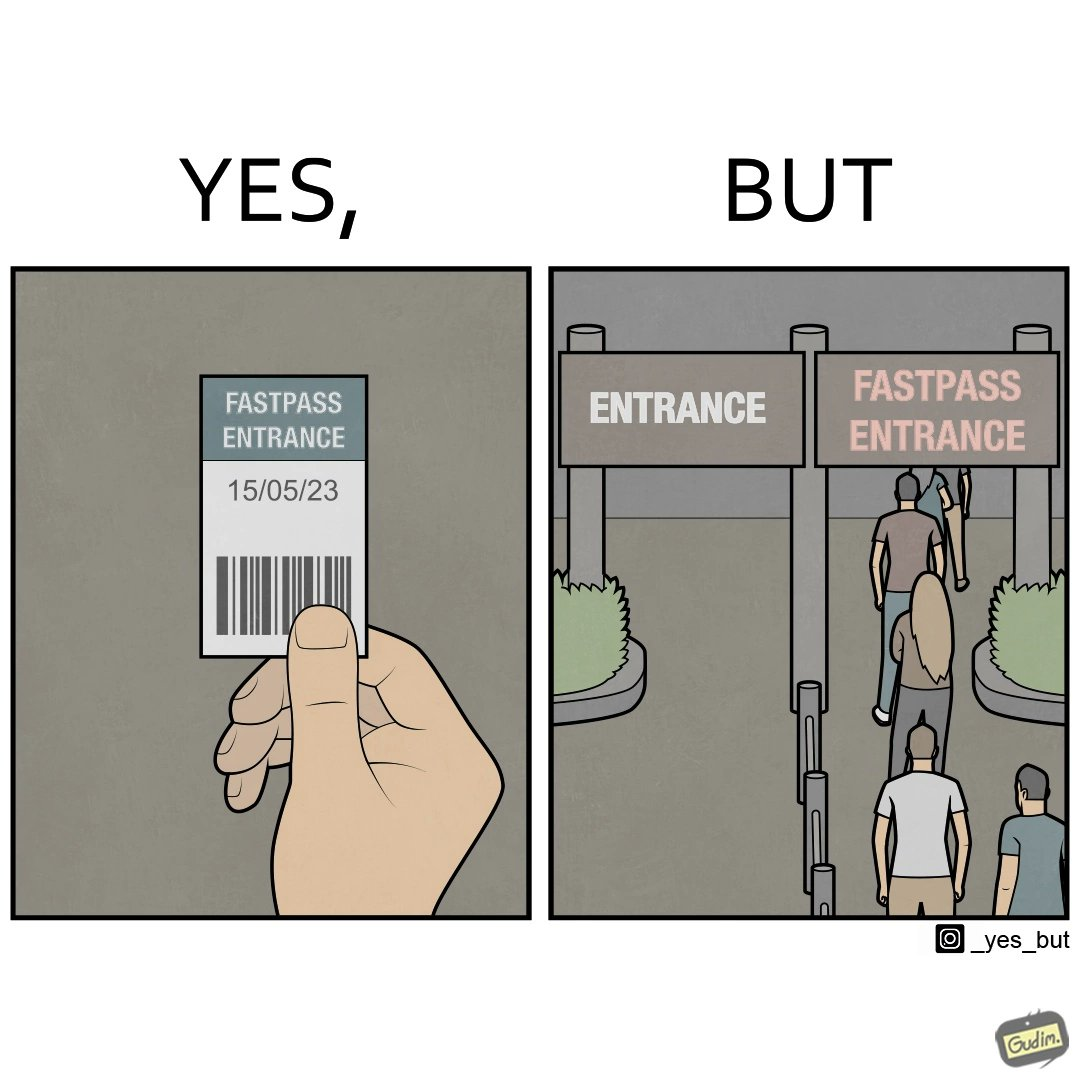Would you classify this image as satirical? Yes, this image is satirical. 